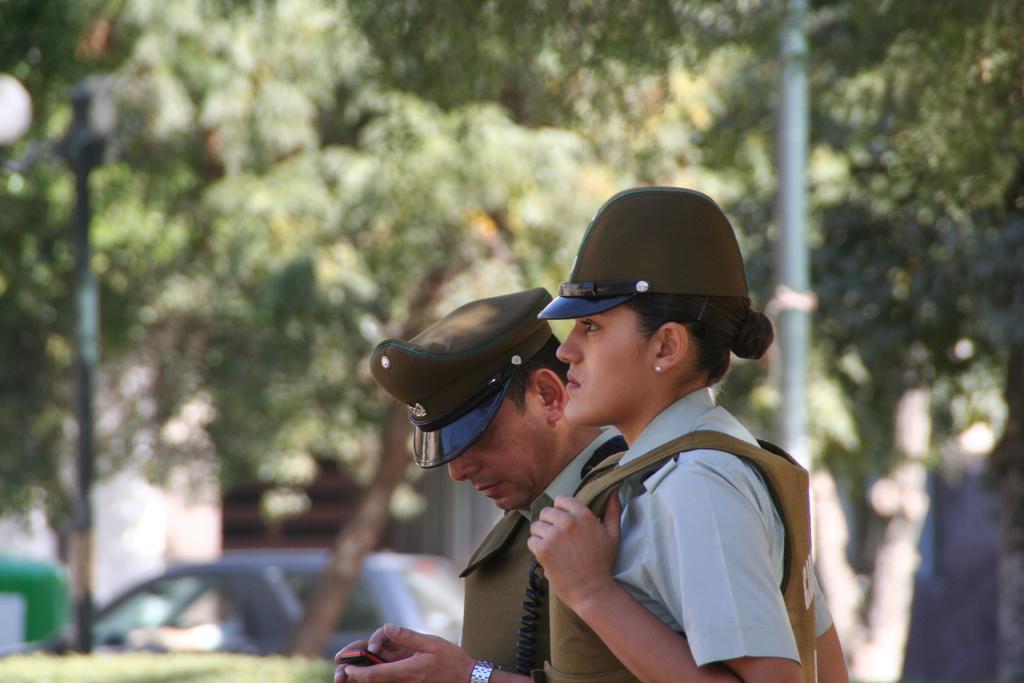Could you give a brief overview of what you see in this image? In this image there is a woman and a man are wearing jackets. They are wearing caps. Person is holding mobile in his hand. Bottom of the image there are few plants. Behind there is a car. Background there are few trees. Behind there is a building. Left side there is street light. Right side there is a pole. 